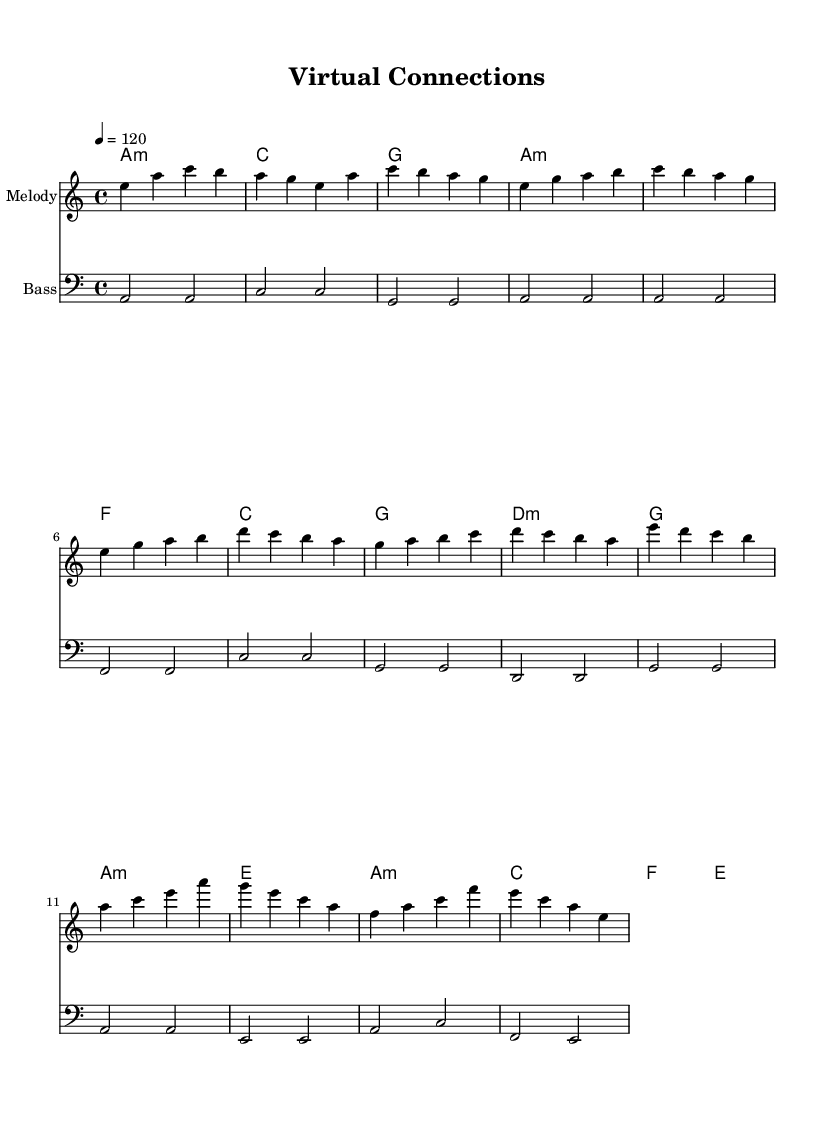What is the key signature of this music? The key signature is indicated by the key at the start of the score, which shows one flat (B♭) indicating A minor as it has no sharps or flats on the staff lines.
Answer: A minor What is the time signature of this piece? The time signature is shown right after the key signature, represented by the numbers, which indicates 4 beats per measure with the quarter note getting the beat.
Answer: 4/4 What is the tempo marking for this composition? The tempo is specified at the beginning of the score with '4 = 120', indicating the beats per minute (BPM) that the melody should be played.
Answer: 120 How many measures are in the chorus section? To determine the number of measures in the chorus, count the number of bars (vertical lines) indicated, which are part of the chorus identified in the given section.
Answer: 4 What is the first chord of the song? The first chord can be found at the beginning of the harmonies and is labeled as A minor which signifies the starting harmony of the music.
Answer: A minor Which section contains a pre-chorus? Identifying sections through their labels, the "Pre-Chorus" is marked clearly in the structure of the piece guiding through the transitions between the verses and chorus.
Answer: Pre-Chorus What is the lowest note in the bassline? The lowest note in the bassline can be seen in the bass clef at the start; it is represented as A2, indicating the lowest pitch used within the piece.
Answer: A2 